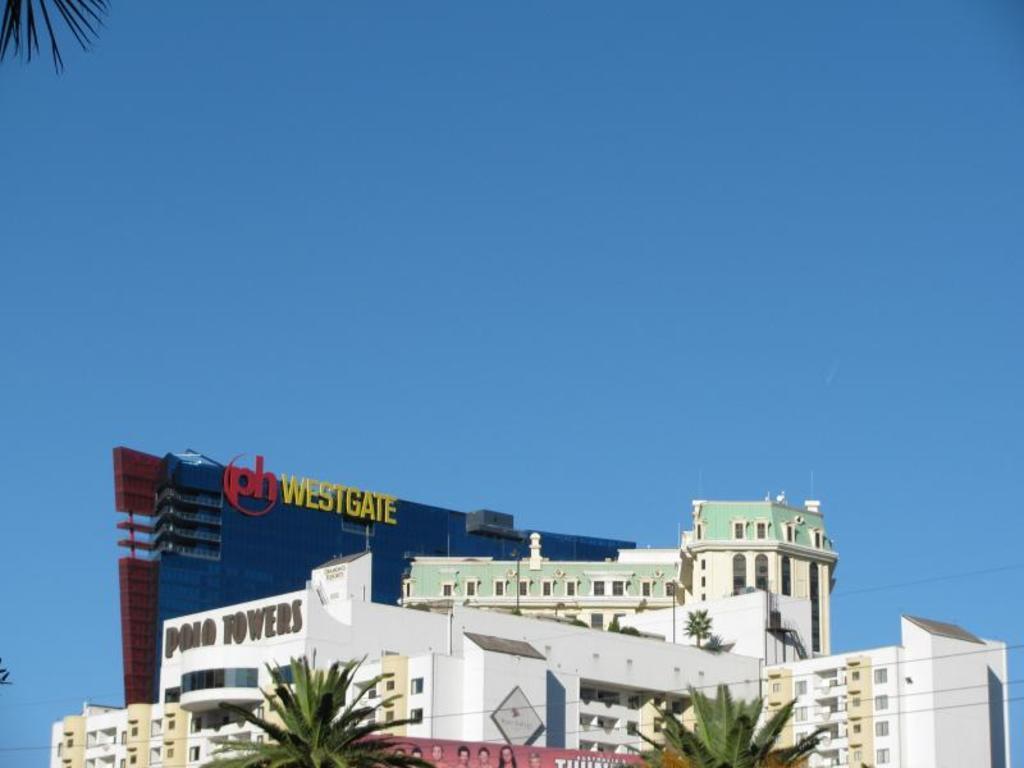Can you describe this image briefly? In this picture we can see a close view of the white buildings. In the front bottom side we can see two coconut trees. Above we can see "West-gate" is written. On the top there is a clear blue sky. 